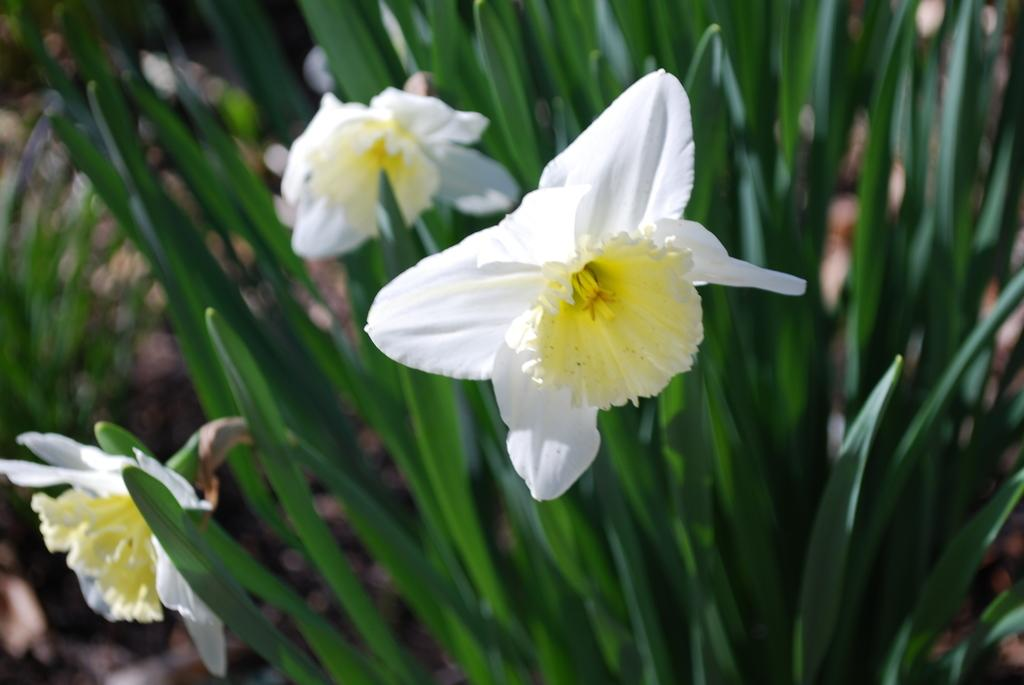What color are the flowers in the image? The flowers in the image are white. How are the flowers described in the image? The flowers are described as beautiful. What other color is present in the image besides white? There are green leaves in the image. Where can the chalk be found in the image? There is no chalk present in the image. What type of animals can be seen at the zoo in the image? There is no zoo or animals present in the image; it features flowers and leaves. 